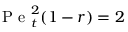Convert formula to latex. <formula><loc_0><loc_0><loc_500><loc_500>P e _ { t } ^ { 2 } ( 1 - r ) = 2</formula> 